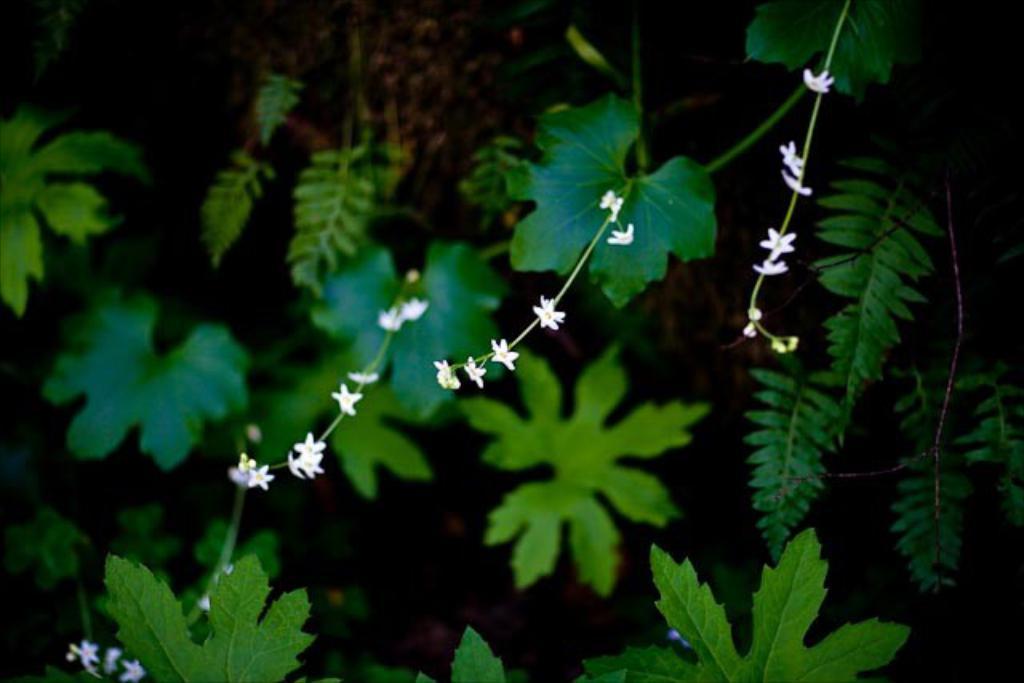Can you describe this image briefly? This image is taken outdoors. In this image there are a few plants with green leaves, stems and white flowers. 